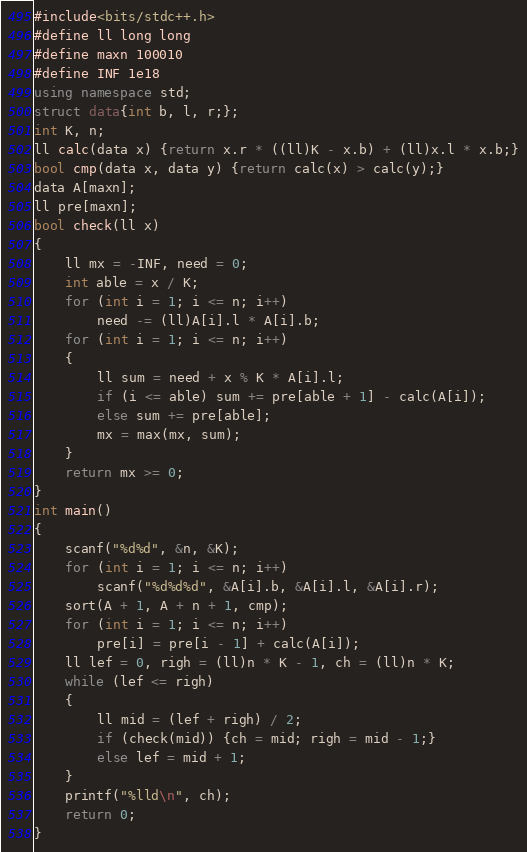<code> <loc_0><loc_0><loc_500><loc_500><_C++_>#include<bits/stdc++.h>
#define ll long long
#define maxn 100010
#define INF 1e18
using namespace std;
struct data{int b, l, r;};
int K, n;
ll calc(data x) {return x.r * ((ll)K - x.b) + (ll)x.l * x.b;}
bool cmp(data x, data y) {return calc(x) > calc(y);}
data A[maxn];
ll pre[maxn];
bool check(ll x)
{
	ll mx = -INF, need = 0;
	int able = x / K;
	for (int i = 1; i <= n; i++)
		need -= (ll)A[i].l * A[i].b;
	for (int i = 1; i <= n; i++)
	{
		ll sum = need + x % K * A[i].l;
		if (i <= able) sum += pre[able + 1] - calc(A[i]);
		else sum += pre[able];
		mx = max(mx, sum);
	}
	return mx >= 0;
}
int main()
{
	scanf("%d%d", &n, &K);
	for (int i = 1; i <= n; i++)
		scanf("%d%d%d", &A[i].b, &A[i].l, &A[i].r);
	sort(A + 1, A + n + 1, cmp);
	for (int i = 1; i <= n; i++)
		pre[i] = pre[i - 1] + calc(A[i]);
	ll lef = 0, righ = (ll)n * K - 1, ch = (ll)n * K;
	while (lef <= righ)
	{
		ll mid = (lef + righ) / 2;
		if (check(mid)) {ch = mid; righ = mid - 1;}
		else lef = mid + 1;
	}
	printf("%lld\n", ch);
	return 0;
}</code> 